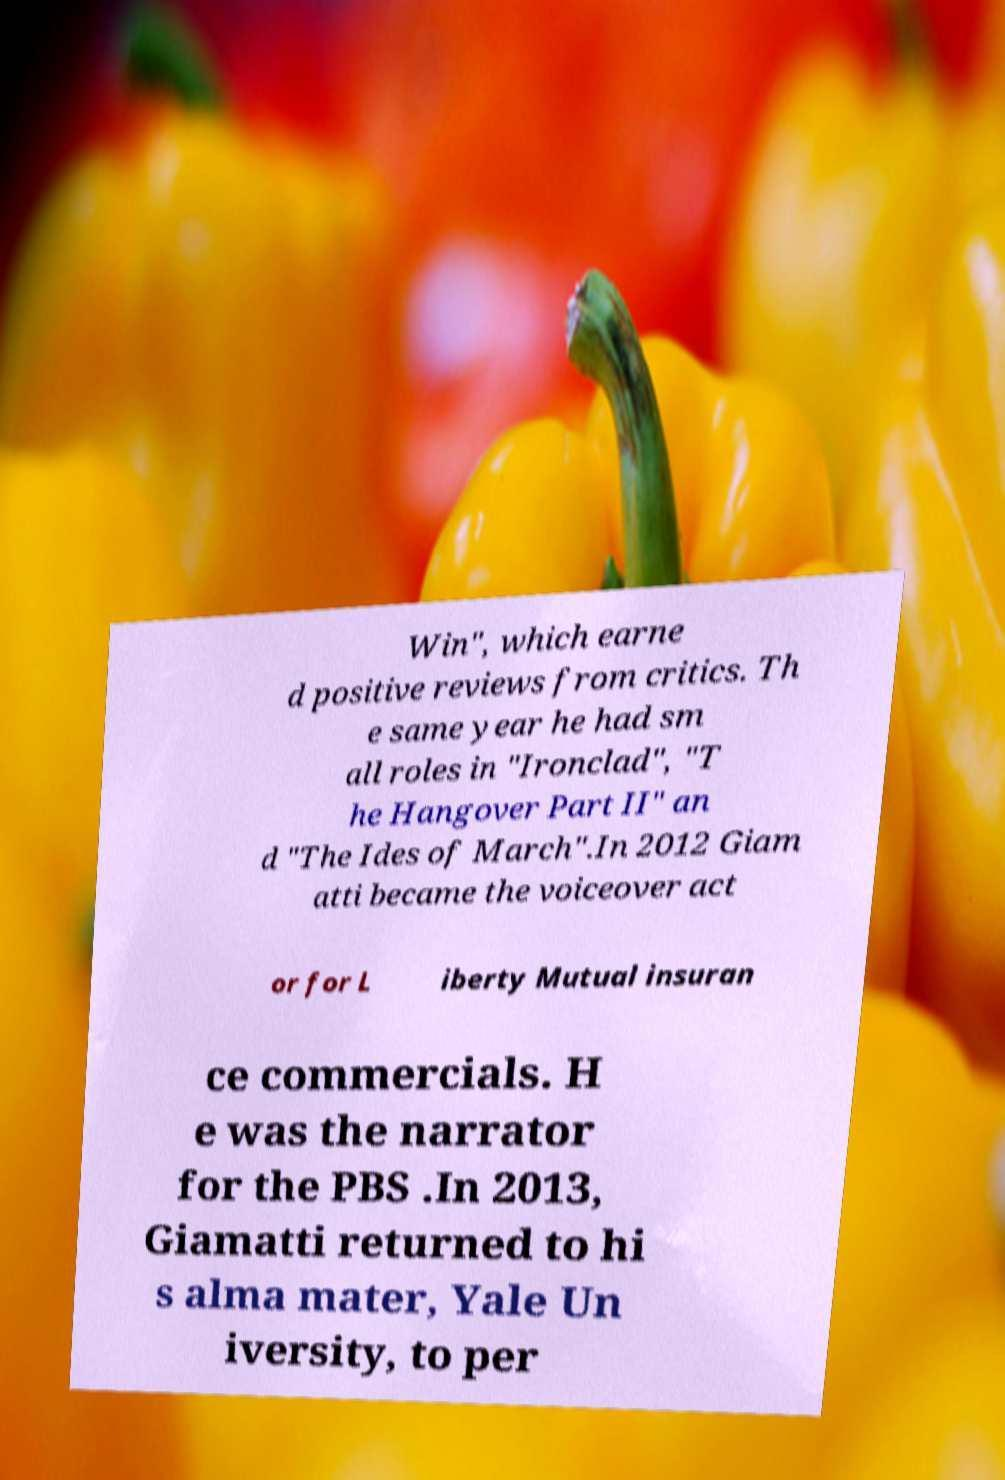Please identify and transcribe the text found in this image. Win", which earne d positive reviews from critics. Th e same year he had sm all roles in "Ironclad", "T he Hangover Part II" an d "The Ides of March".In 2012 Giam atti became the voiceover act or for L iberty Mutual insuran ce commercials. H e was the narrator for the PBS .In 2013, Giamatti returned to hi s alma mater, Yale Un iversity, to per 